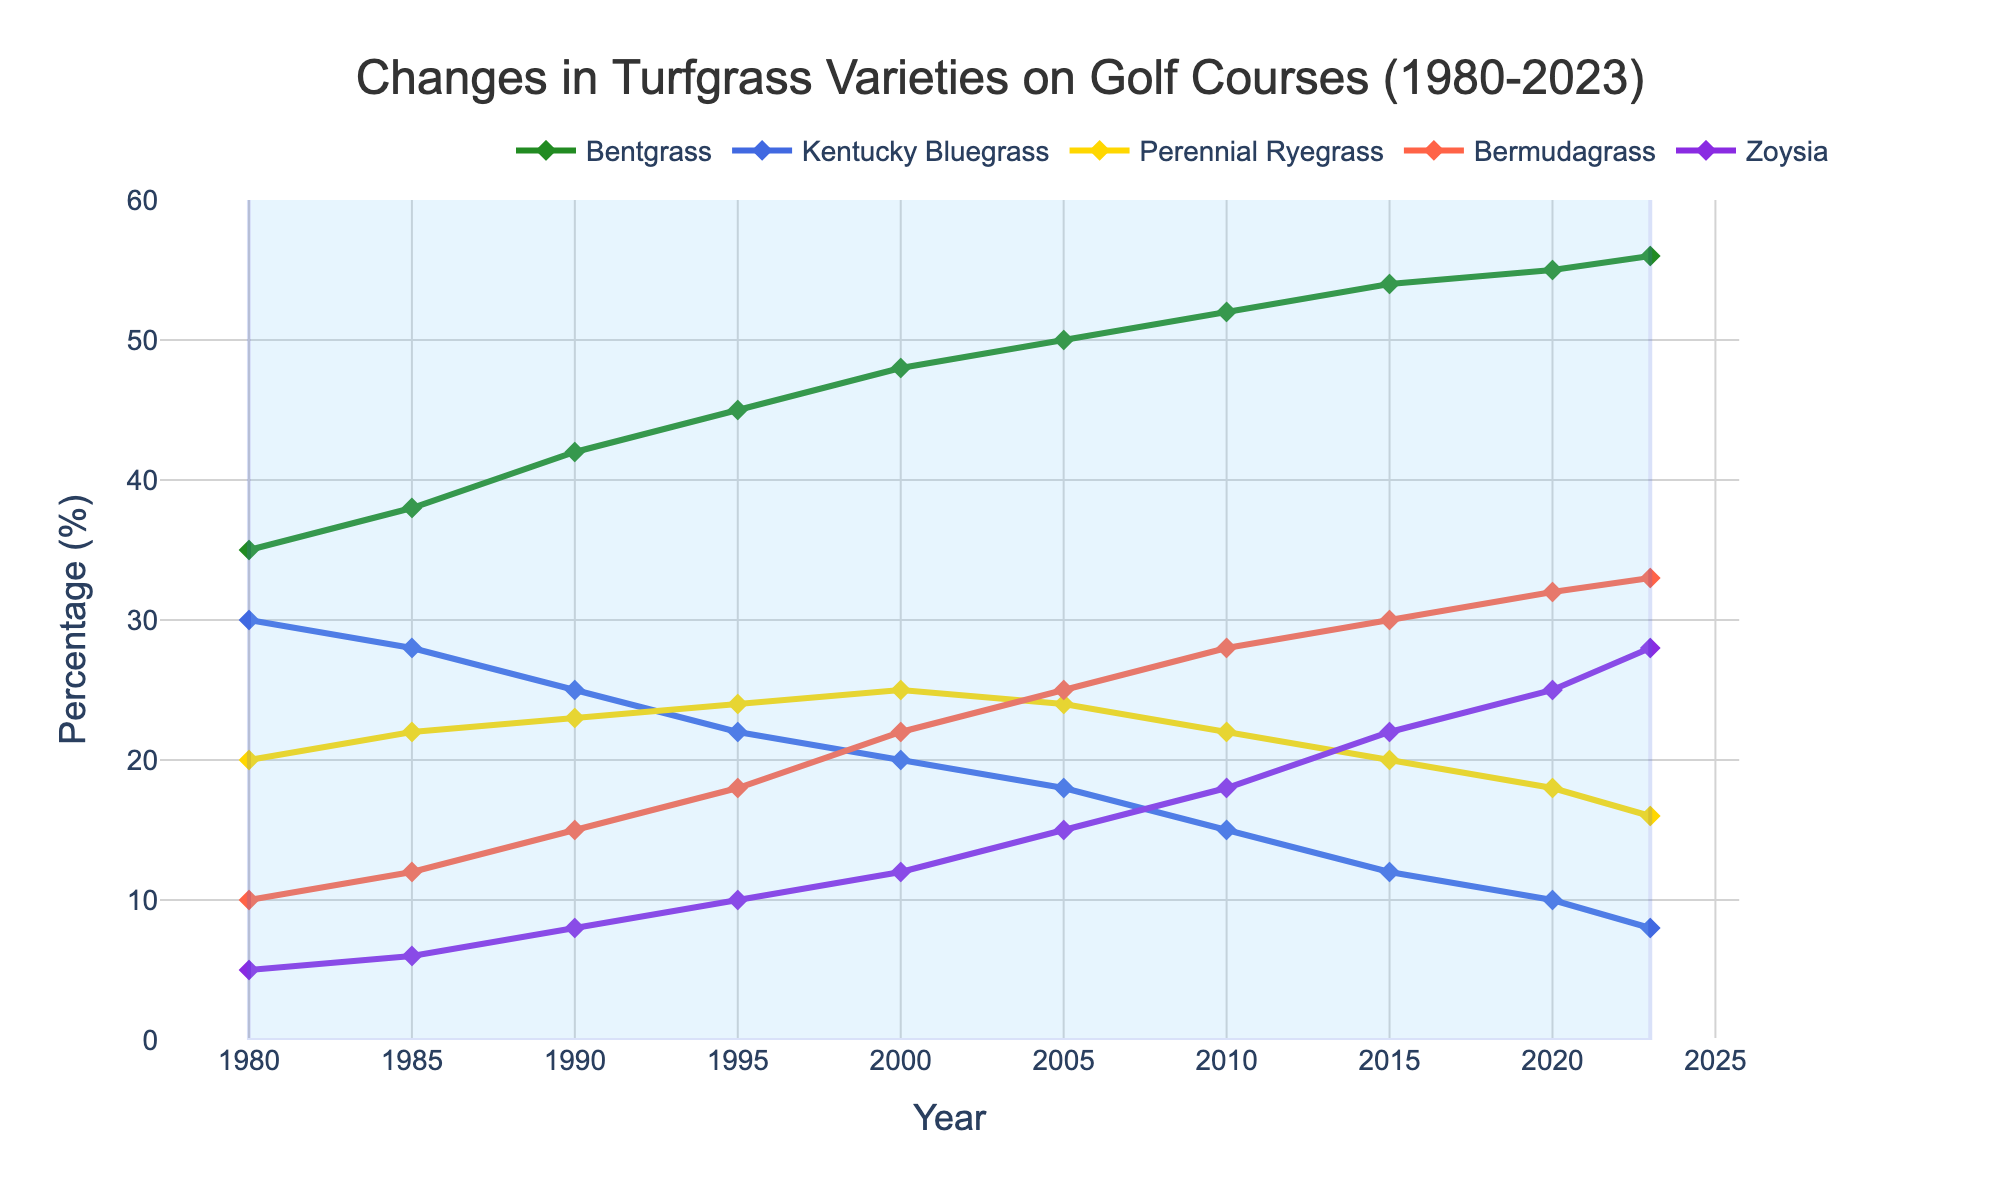What has been the general trend of Bentgrass usage from 1980 to 2023? Observing the line for Bentgrass, its percentage has increased steadily from 35% in 1980 to 56% in 2023.
Answer: Increased Which turfgrass variety had the highest increase in percentage from 1980 to 2023? By comparing the end values of each variety in 2023 to their initial values in 1980, Bentgrass increased by 21% (56% - 35%). Bermudagrass increased by 23% (33% - 10%), Zoysia increased by 23% (28% - 5%). Thus, both Bermudagrass and Zoysia had the highest increase of 23%.
Answer: Bermudagrass and Zoysia How did the percentage of Kentucky Bluegrass change from 1980 to 2023? The percentage of Kentucky Bluegrass decreased from 30% in 1980 to 8% in 2023.
Answer: Decreased Which turfgrass variety showed the most stability in usage percentage over the years? Perennial Ryegrass had the smallest change, with only a variation from 20% in 1980 to 16% in 2023.
Answer: Perennial Ryegrass In what year did Bentgrass surpass Kentucky Bluegrass in percentage usage? Bentgrass surpassed Kentucky Bluegrass in the year 1990 when Bentgrass was at 42% and Kentucky Bluegrass was at 25%.
Answer: 1990 What is the difference in percentage usage between Bentgrass and Bermudagrass in 2023? In 2023, Bentgrass is at 56%, and Bermudagrass is at 33%, so the difference is 56% - 33%.
Answer: 23% Which three turfgrass varieties had the highest combined percentage in 2023? In 2023, the percentages are Bentgrass (56%), Bermudagrass (33%), and Zoysia (28%). The combined percentage is 56% + 33% + 28%.
Answer: 117% Compare the increase rates of Bentgrass and Bermudagrass from 1980 to 2000. Which increased faster? Bentgrass increased from 35% to 48% (+13%). Bermudagrass increased from 10% to 22% (+12%) in the same period. Bentgrass increased faster.
Answer: Bentgrass What visual feature highlights the start and end period of the analysis? A rectangular shape covers the period from 1980 to 2023, highlighted with a light blue fill and a blue border.
Answer: Rectangular shape with light blue fill 